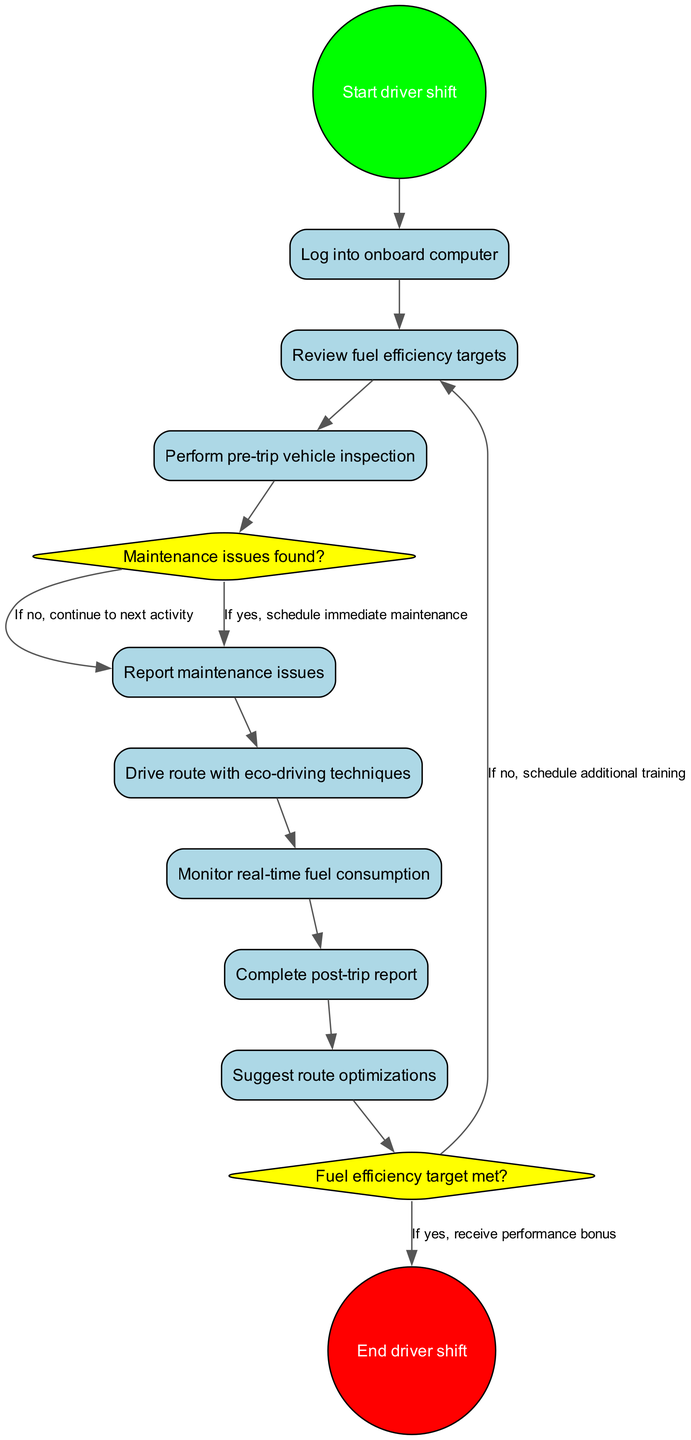What's the initial node in the diagram? The initial node is labeled as "Start driver shift." It is indicated at the top of the diagram, representing the beginning of the driver's activities.
Answer: Start driver shift How many activities are listed in the diagram? The diagram contains eight activities, each represented as rectangular nodes in a sequential flow, starting from logging into the onboard computer to suggesting route optimizations.
Answer: 8 What happens if maintenance issues are found during the pre-trip vehicle inspection? If maintenance issues are found, the flow indicates that the driver should schedule immediate maintenance, which connects to the maintenance reporting activity.
Answer: Schedule immediate maintenance What is the outcome if the fuel efficiency target is met? If the fuel efficiency target is met, according to the diagram, the driver receives a performance bonus, indicated by the connection from the decision node to that outcome.
Answer: Receive performance bonus What activity follows the decision of "Fuel efficiency target met?" After this decision, if the target is not met, the flow leads to scheduling additional training, which is another activity connected to the decision node.
Answer: Schedule additional training Which activity involves real-time analysis? The activity that involves real-time analysis is "Monitor real-time fuel consumption," representing ongoing tracking of fuel efficiency during the route.
Answer: Monitor real-time fuel consumption What decision is made after the "Complete post-trip report" activity? After completing the post-trip report, the decision made is whether the fuel efficiency target is met, indicating the assessment of performance based on the driving behavior.
Answer: Fuel efficiency target met? What is the final activity before the end of the driver shift? The last activity before reaching the end node is "Suggest route optimizations," which allows drivers to provide feedback and propose changes to routes for better fuel efficiency.
Answer: Suggest route optimizations What color represents the decision nodes in the diagram? The decision nodes in the diagram are represented in yellow, distinguishing them from the activities and initial/final nodes in other colors.
Answer: Yellow 